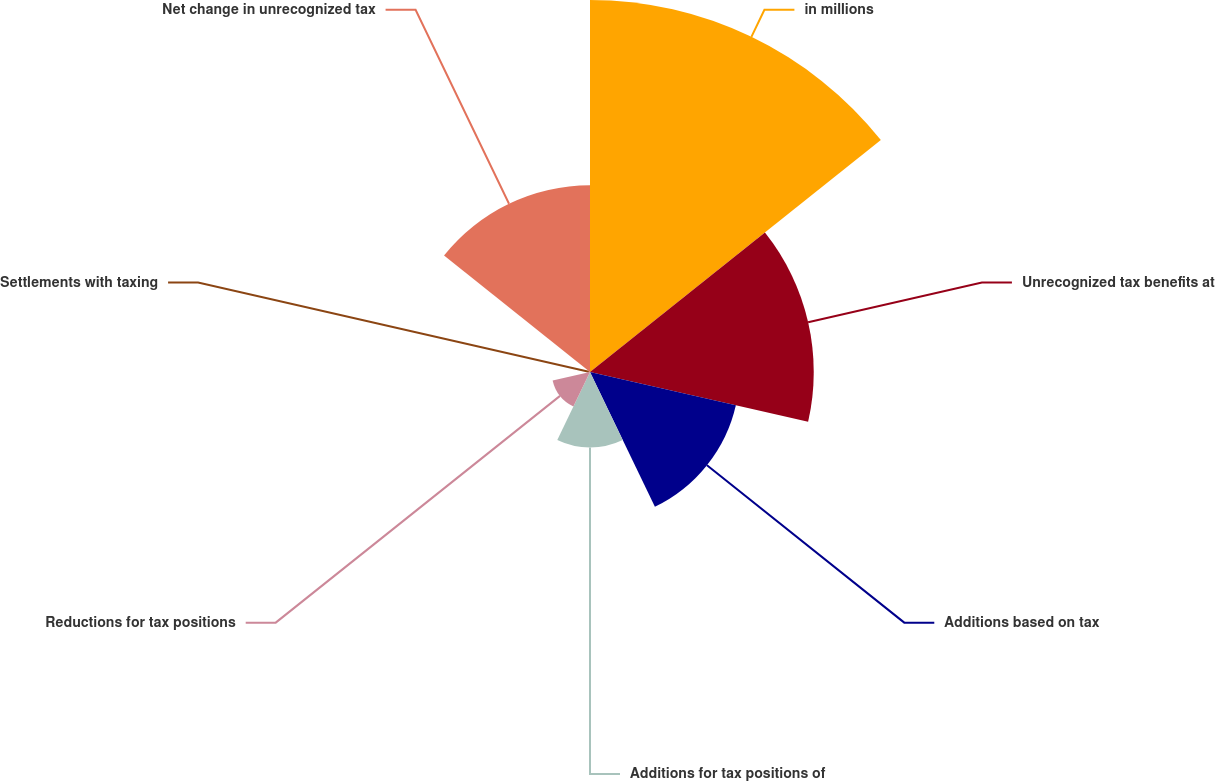Convert chart. <chart><loc_0><loc_0><loc_500><loc_500><pie_chart><fcel>in millions<fcel>Unrecognized tax benefits at<fcel>Additions based on tax<fcel>Additions for tax positions of<fcel>Reductions for tax positions<fcel>Settlements with taxing<fcel>Net change in unrecognized tax<nl><fcel>35.53%<fcel>21.37%<fcel>14.29%<fcel>7.2%<fcel>3.66%<fcel>0.12%<fcel>17.83%<nl></chart> 